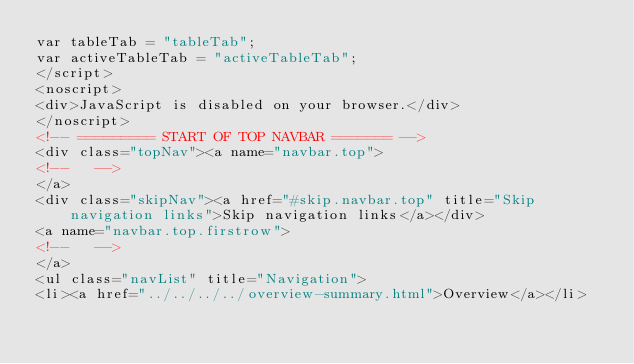Convert code to text. <code><loc_0><loc_0><loc_500><loc_500><_HTML_>var tableTab = "tableTab";
var activeTableTab = "activeTableTab";
</script>
<noscript>
<div>JavaScript is disabled on your browser.</div>
</noscript>
<!-- ========= START OF TOP NAVBAR ======= -->
<div class="topNav"><a name="navbar.top">
<!--   -->
</a>
<div class="skipNav"><a href="#skip.navbar.top" title="Skip navigation links">Skip navigation links</a></div>
<a name="navbar.top.firstrow">
<!--   -->
</a>
<ul class="navList" title="Navigation">
<li><a href="../../../../overview-summary.html">Overview</a></li></code> 